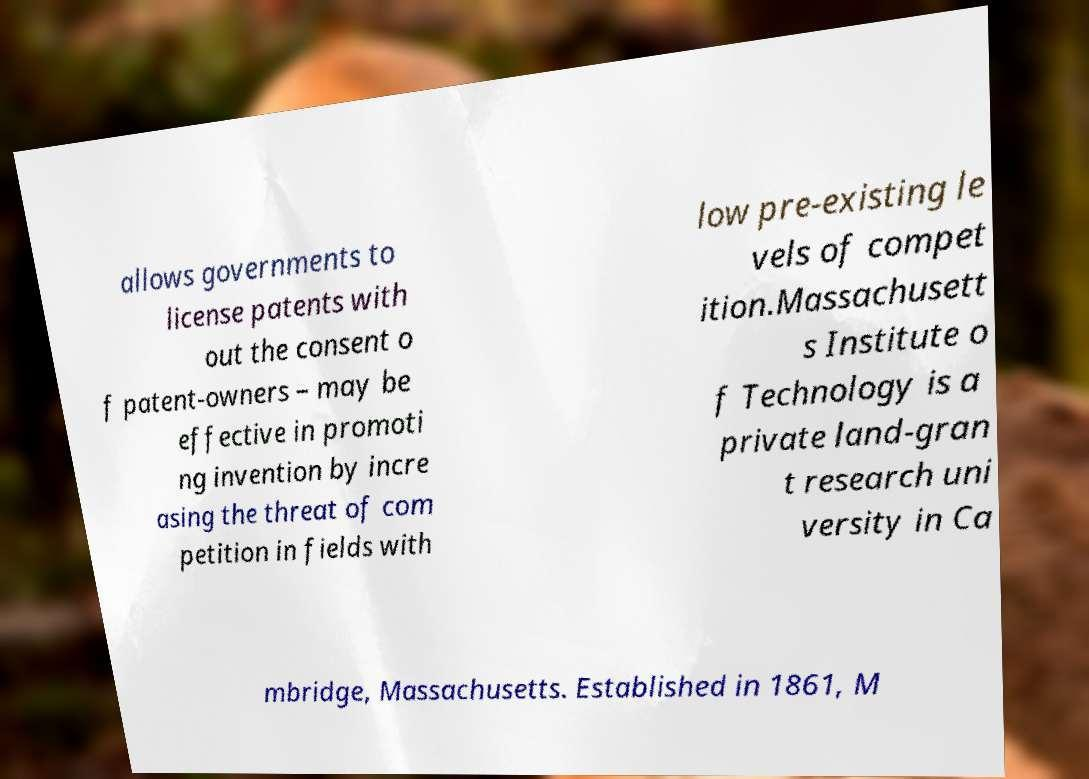I need the written content from this picture converted into text. Can you do that? allows governments to license patents with out the consent o f patent-owners – may be effective in promoti ng invention by incre asing the threat of com petition in fields with low pre-existing le vels of compet ition.Massachusett s Institute o f Technology is a private land-gran t research uni versity in Ca mbridge, Massachusetts. Established in 1861, M 